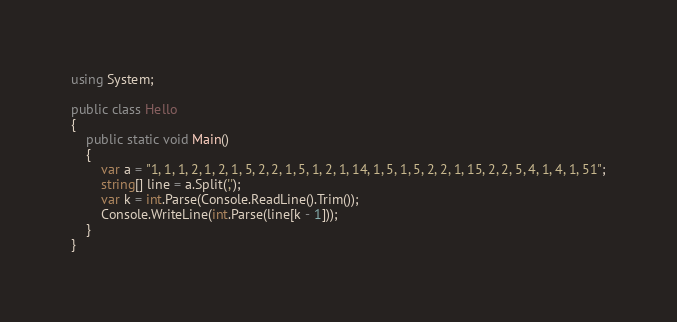<code> <loc_0><loc_0><loc_500><loc_500><_C#_>using System;

public class Hello
{
    public static void Main()
    {
        var a = "1, 1, 1, 2, 1, 2, 1, 5, 2, 2, 1, 5, 1, 2, 1, 14, 1, 5, 1, 5, 2, 2, 1, 15, 2, 2, 5, 4, 1, 4, 1, 51";
        string[] line = a.Split(',');
        var k = int.Parse(Console.ReadLine().Trim());
        Console.WriteLine(int.Parse(line[k - 1]));
    }
}</code> 